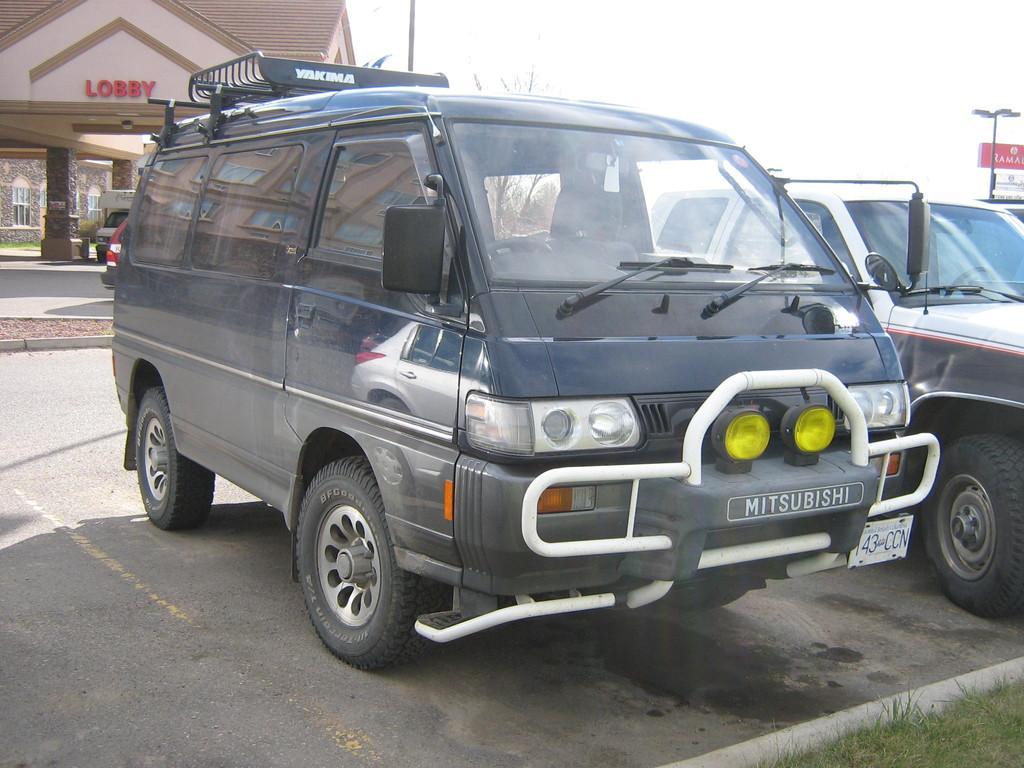In one or two sentences, can you explain what this image depicts? In this image we can see some vehicles on the road, there is a house, grass, tree, pillars, board with some text written on it, also we can see the sky, light pole. 